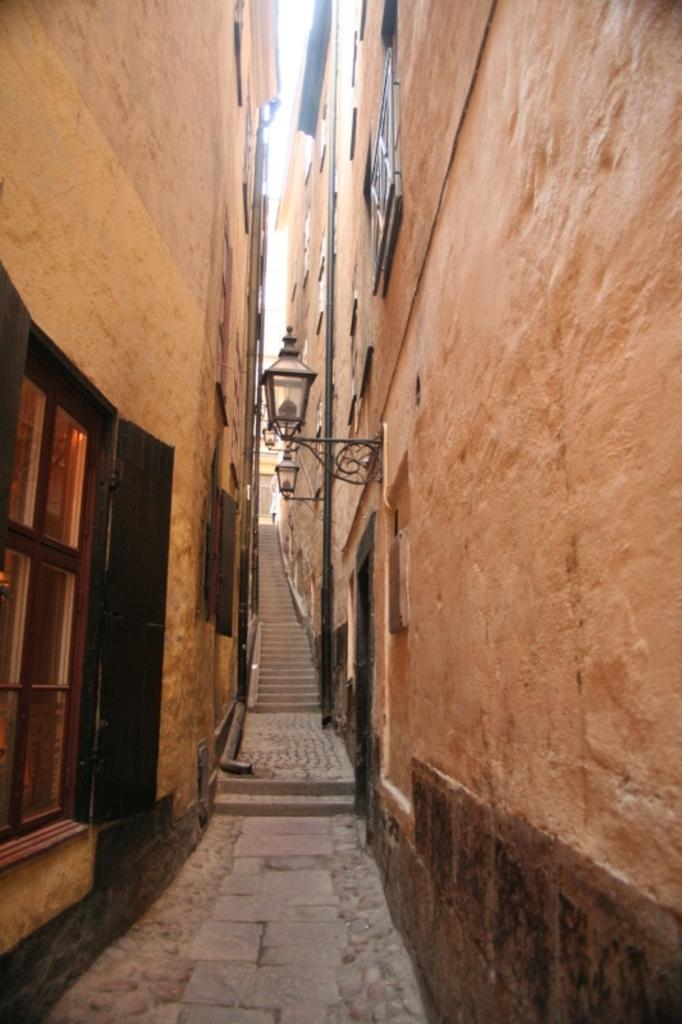What type of structures can be seen in the image? There are buildings in the image. Are there any architectural features present in the image? Yes, there are steps in the image. What can be found attached to the wall in the image? There are lights attached to the wall in the image. What is a feature that allows for natural light in the image? There is a window in the image. What can be seen in the background of the image? The sky is visible in the background of the image. What type of bean is being used as an example in the image? There is no bean present in the image, and therefore no example can be observed. What type of voyage is depicted in the image? There is no voyage depicted in the image; it features buildings, steps, lights, a window, and the sky. 